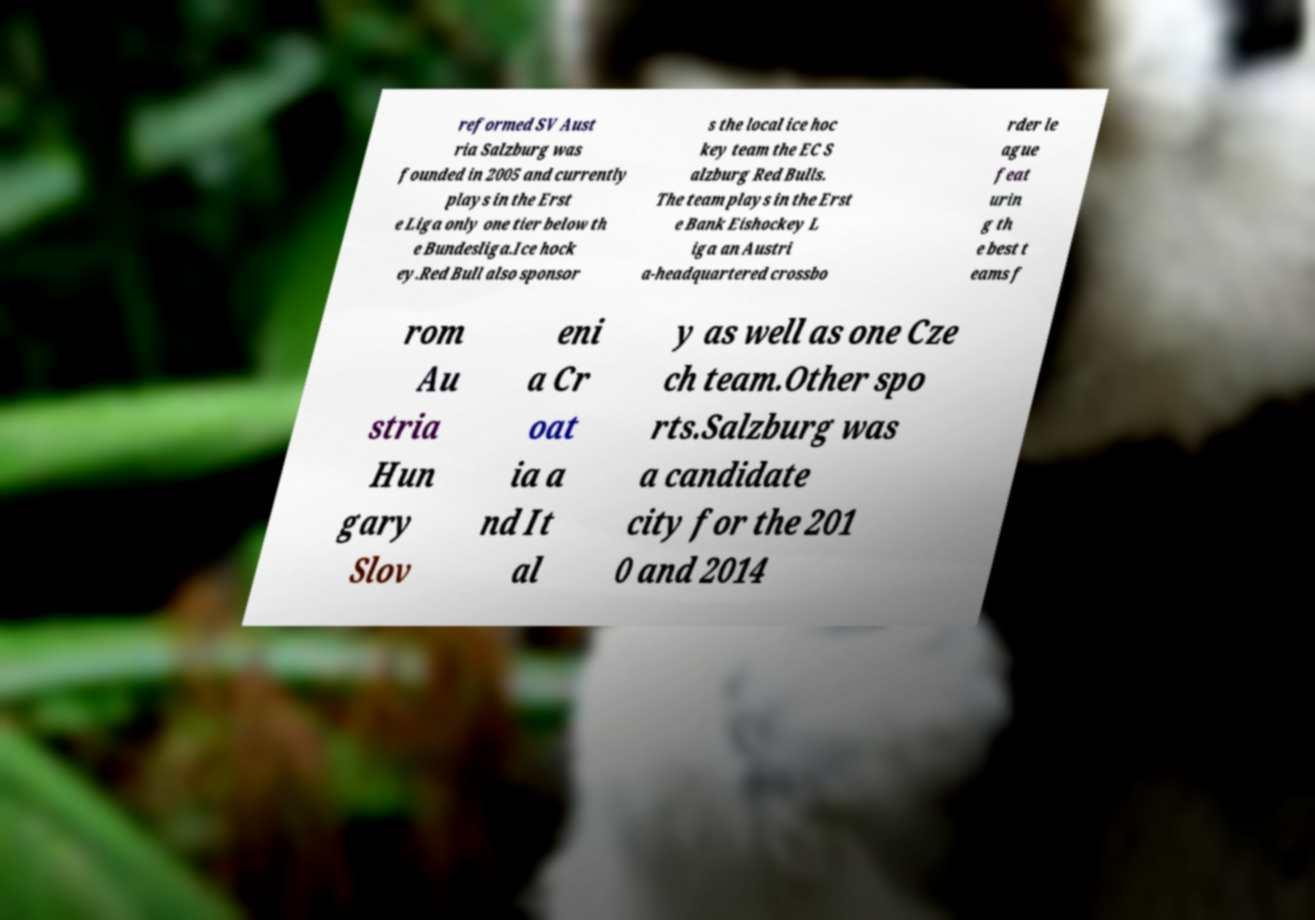Can you read and provide the text displayed in the image?This photo seems to have some interesting text. Can you extract and type it out for me? reformed SV Aust ria Salzburg was founded in 2005 and currently plays in the Erst e Liga only one tier below th e Bundesliga.Ice hock ey.Red Bull also sponsor s the local ice hoc key team the EC S alzburg Red Bulls. The team plays in the Erst e Bank Eishockey L iga an Austri a-headquartered crossbo rder le ague feat urin g th e best t eams f rom Au stria Hun gary Slov eni a Cr oat ia a nd It al y as well as one Cze ch team.Other spo rts.Salzburg was a candidate city for the 201 0 and 2014 